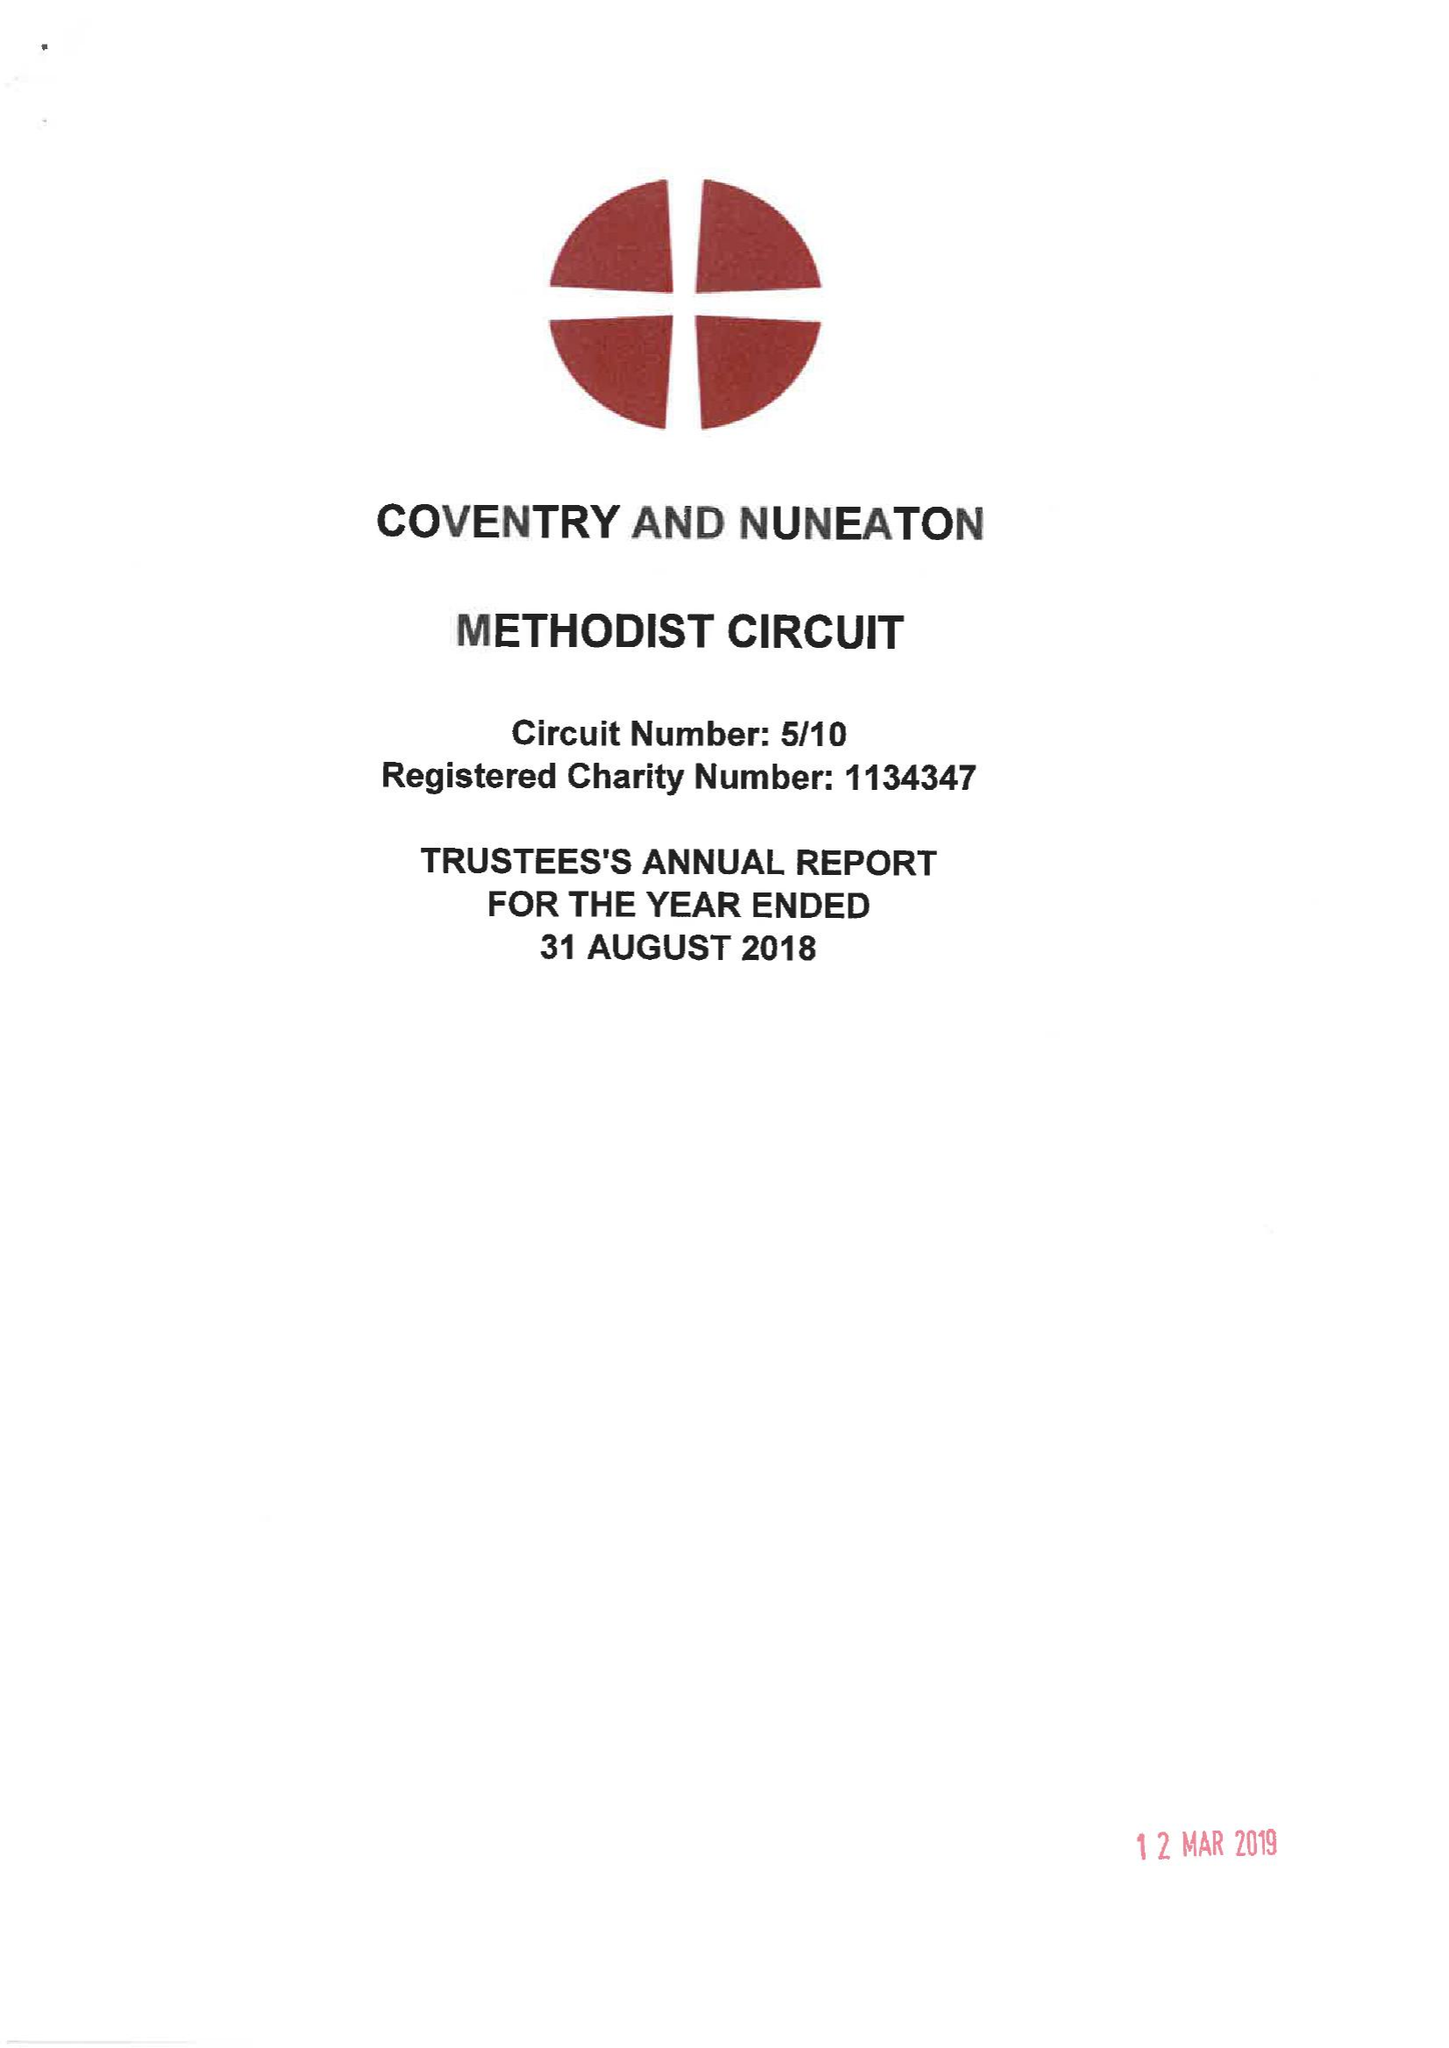What is the value for the charity_name?
Answer the question using a single word or phrase. Coventry and Nuneaton Methodist Circuit 